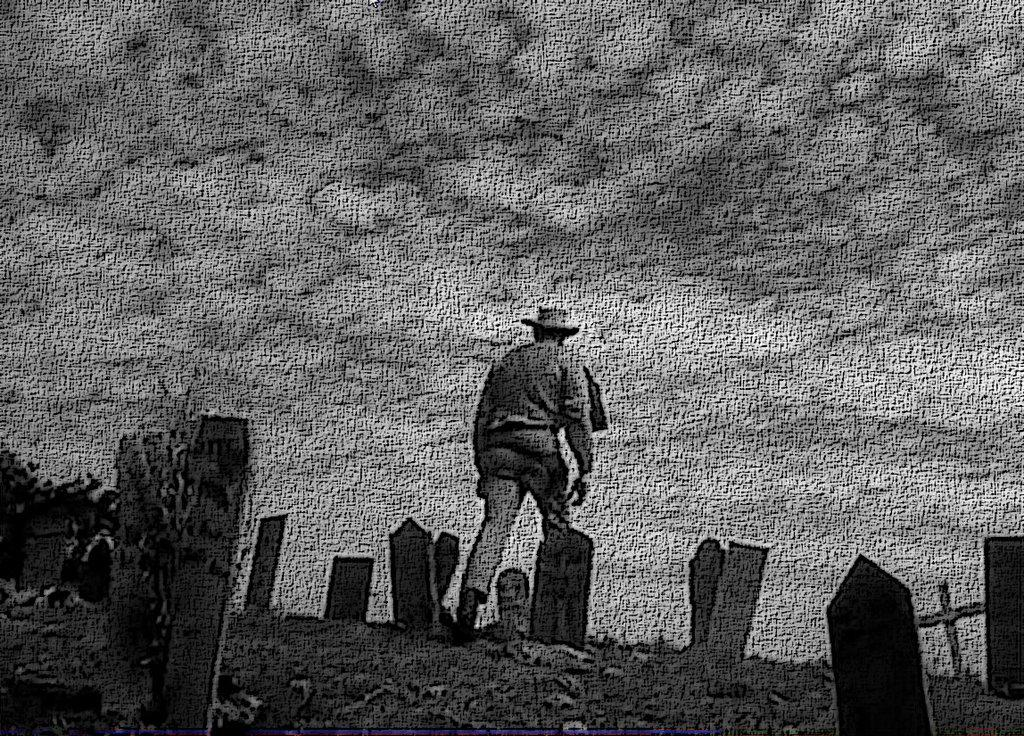Who or what is present in the image? There is a person in the image. What type of objects can be seen in the image? There are memorial stones in the image. What part of the natural environment is visible in the image? The sky is visible in the image. Can you see a railway or an office in the image? No, there is no railway or office present in the image. Is there a river visible in the image? No, there is no river visible in the image. 